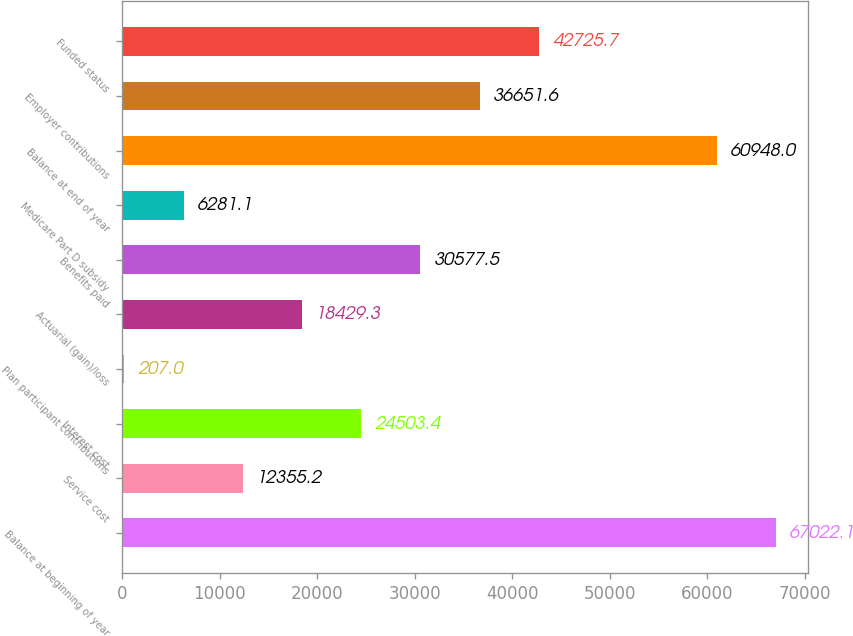Convert chart to OTSL. <chart><loc_0><loc_0><loc_500><loc_500><bar_chart><fcel>Balance at beginning of year<fcel>Service cost<fcel>Interest cost<fcel>Plan participant contributions<fcel>Actuarial (gain)/loss<fcel>Benefits paid<fcel>Medicare Part D subsidy<fcel>Balance at end of year<fcel>Employer contributions<fcel>Funded status<nl><fcel>67022.1<fcel>12355.2<fcel>24503.4<fcel>207<fcel>18429.3<fcel>30577.5<fcel>6281.1<fcel>60948<fcel>36651.6<fcel>42725.7<nl></chart> 